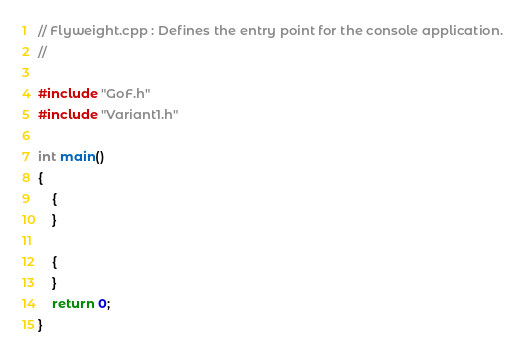Convert code to text. <code><loc_0><loc_0><loc_500><loc_500><_C++_>// Flyweight.cpp : Defines the entry point for the console application.
//

#include "GoF.h"
#include "Variant1.h"

int main()
{
	{
	}

	{
	}
    return 0;
}

</code> 